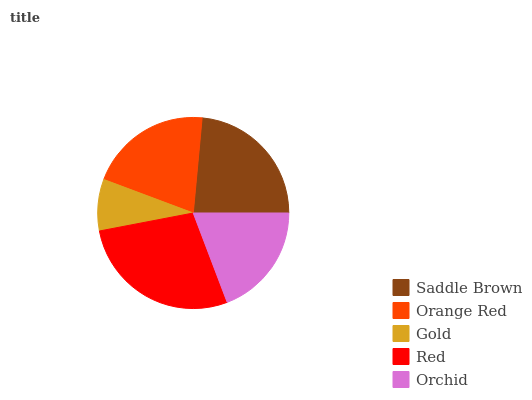Is Gold the minimum?
Answer yes or no. Yes. Is Red the maximum?
Answer yes or no. Yes. Is Orange Red the minimum?
Answer yes or no. No. Is Orange Red the maximum?
Answer yes or no. No. Is Saddle Brown greater than Orange Red?
Answer yes or no. Yes. Is Orange Red less than Saddle Brown?
Answer yes or no. Yes. Is Orange Red greater than Saddle Brown?
Answer yes or no. No. Is Saddle Brown less than Orange Red?
Answer yes or no. No. Is Orange Red the high median?
Answer yes or no. Yes. Is Orange Red the low median?
Answer yes or no. Yes. Is Saddle Brown the high median?
Answer yes or no. No. Is Saddle Brown the low median?
Answer yes or no. No. 